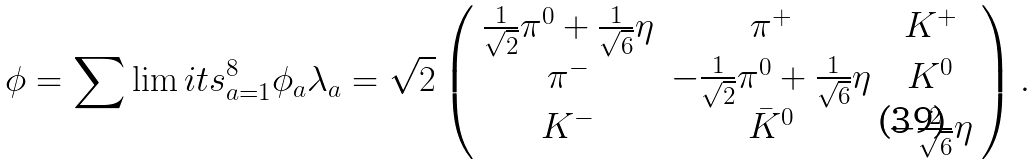Convert formula to latex. <formula><loc_0><loc_0><loc_500><loc_500>\phi = \sum \lim i t s _ { a = 1 } ^ { 8 } \phi _ { a } \lambda _ { a } = \sqrt { 2 } \left ( \begin{array} { c c c } \frac { 1 } { \sqrt { 2 } } \pi ^ { 0 } + \frac { 1 } { \sqrt { 6 } } \eta & \pi ^ { + } & K ^ { + } \\ \pi ^ { - } & - \frac { 1 } { \sqrt { 2 } } \pi ^ { 0 } + \frac { 1 } { \sqrt { 6 } } \eta & K ^ { 0 } \\ K ^ { - } & \bar { K } ^ { 0 } & - \frac { 2 } { \sqrt { 6 } } \eta \end{array} \right ) .</formula> 